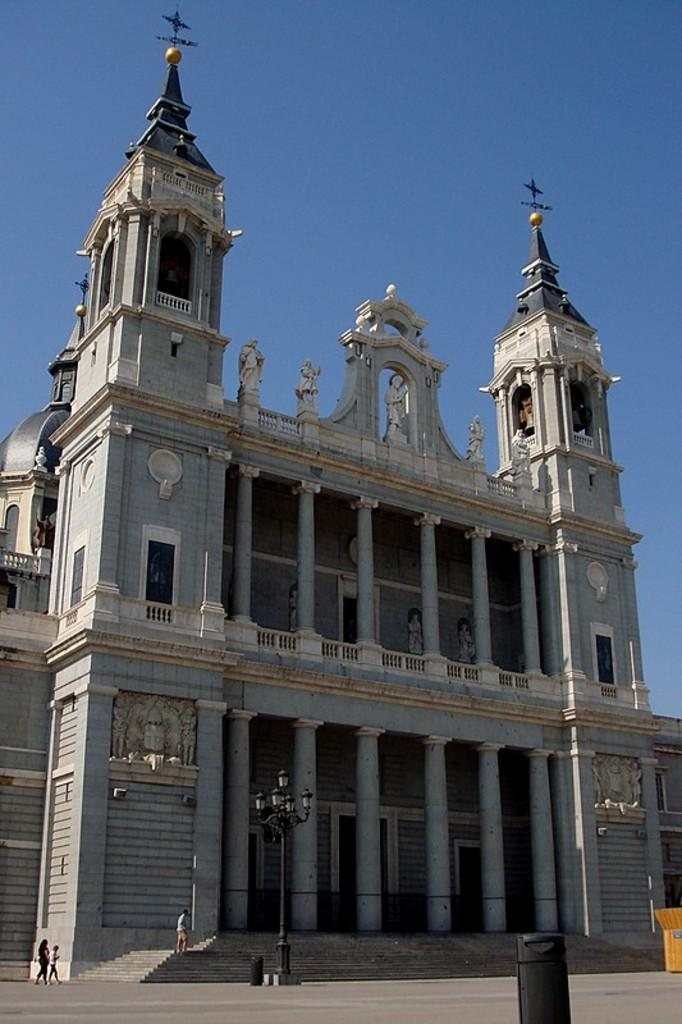What can be seen on the ground in the image? There are people on the ground in the image. What is attached to the electric pole in the image? There are lights on the electric pole in the image. What else is near the electric pole in the image? There are some objects near the electric pole. What can be seen in the background of the image? There is a building and the sky visible in the background of the image. What type of game is being played by the people in the image? There is no game being played in the image; it only shows people on the ground and an electric pole with lights. Can you tell me how many grandmothers are present in the image? There is no mention of a grandmother in the image; it only shows people on the ground and an electric pole with lights. 